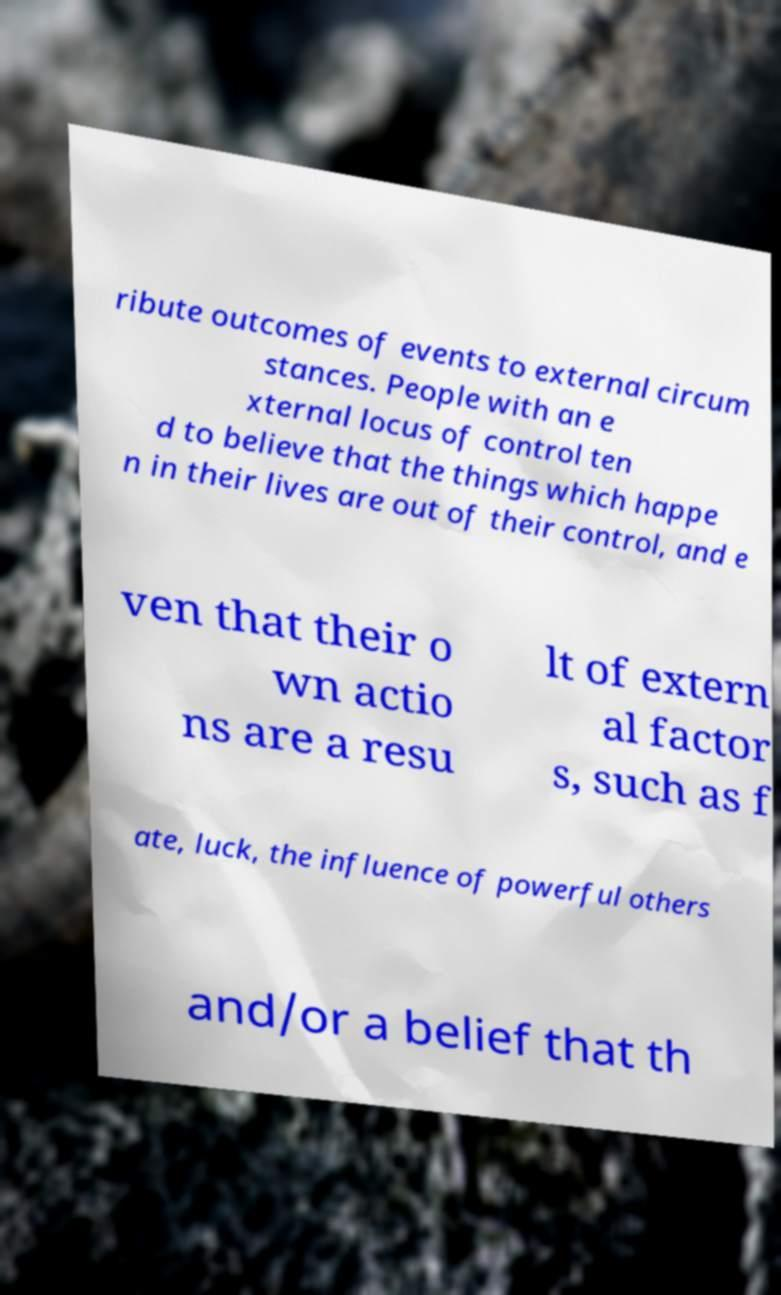Could you extract and type out the text from this image? ribute outcomes of events to external circum stances. People with an e xternal locus of control ten d to believe that the things which happe n in their lives are out of their control, and e ven that their o wn actio ns are a resu lt of extern al factor s, such as f ate, luck, the influence of powerful others and/or a belief that th 